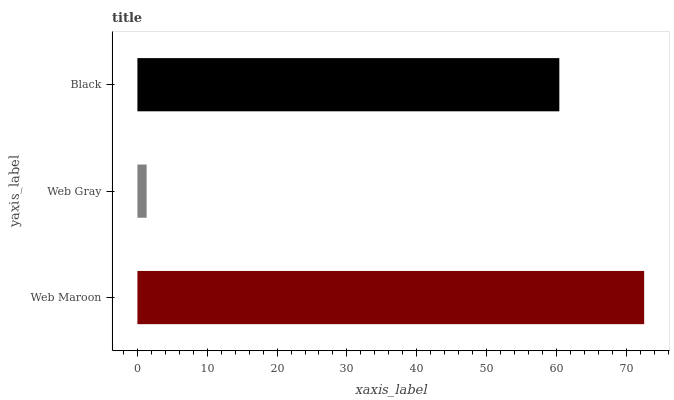Is Web Gray the minimum?
Answer yes or no. Yes. Is Web Maroon the maximum?
Answer yes or no. Yes. Is Black the minimum?
Answer yes or no. No. Is Black the maximum?
Answer yes or no. No. Is Black greater than Web Gray?
Answer yes or no. Yes. Is Web Gray less than Black?
Answer yes or no. Yes. Is Web Gray greater than Black?
Answer yes or no. No. Is Black less than Web Gray?
Answer yes or no. No. Is Black the high median?
Answer yes or no. Yes. Is Black the low median?
Answer yes or no. Yes. Is Web Maroon the high median?
Answer yes or no. No. Is Web Gray the low median?
Answer yes or no. No. 